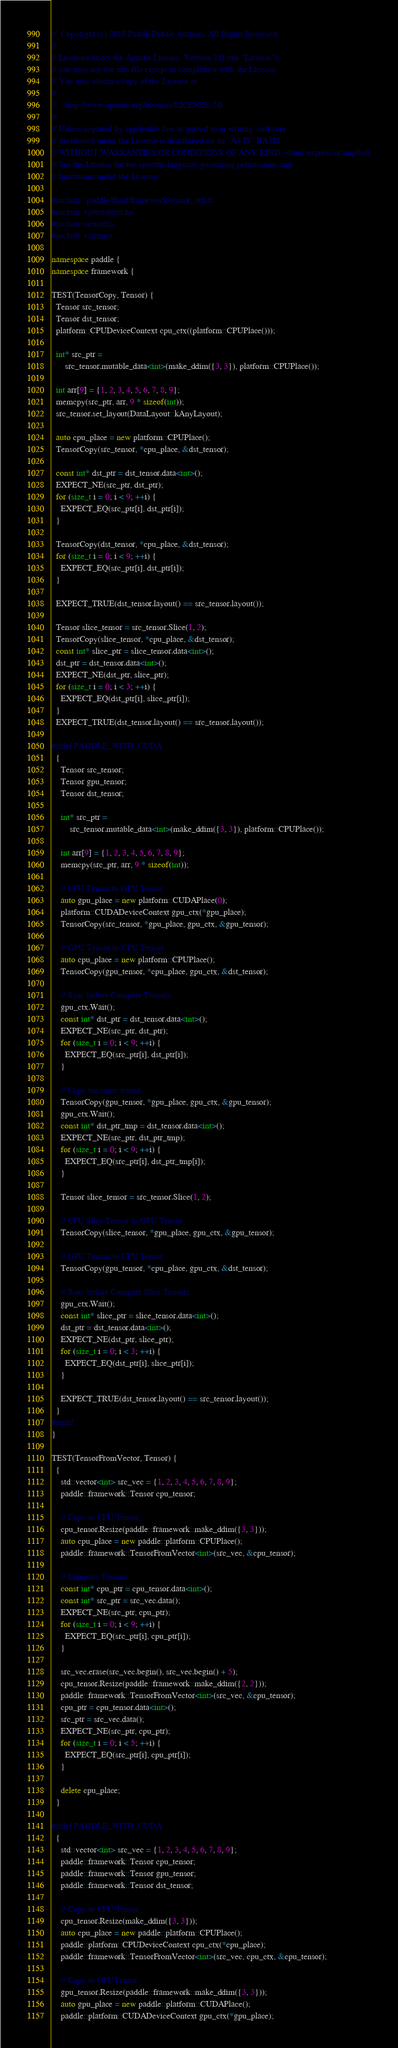<code> <loc_0><loc_0><loc_500><loc_500><_C++_>//  Copyright (c) 2018 PaddlePaddle Authors. All Rights Reserved.
//
// Licensed under the Apache License, Version 2.0 (the "License");
// you may not use this file except in compliance with the License.
// You may obtain a copy of the License at
//
//    http://www.apache.org/licenses/LICENSE-2.0
//
// Unless required by applicable law or agreed to in writing, software
// distributed under the License is distributed on an "AS IS" BASIS,
// WITHOUT WARRANTIES OR CONDITIONS OF ANY KIND, either express or implied.
// See the License for the specific language governing permissions and
// limitations under the License.

#include "paddle/fluid/framework/tensor_util.h"
#include <gtest/gtest.h>
#include <cmath>
#include <string>

namespace paddle {
namespace framework {

TEST(TensorCopy, Tensor) {
  Tensor src_tensor;
  Tensor dst_tensor;
  platform::CPUDeviceContext cpu_ctx((platform::CPUPlace()));

  int* src_ptr =
      src_tensor.mutable_data<int>(make_ddim({3, 3}), platform::CPUPlace());

  int arr[9] = {1, 2, 3, 4, 5, 6, 7, 8, 9};
  memcpy(src_ptr, arr, 9 * sizeof(int));
  src_tensor.set_layout(DataLayout::kAnyLayout);

  auto cpu_place = new platform::CPUPlace();
  TensorCopy(src_tensor, *cpu_place, &dst_tensor);

  const int* dst_ptr = dst_tensor.data<int>();
  EXPECT_NE(src_ptr, dst_ptr);
  for (size_t i = 0; i < 9; ++i) {
    EXPECT_EQ(src_ptr[i], dst_ptr[i]);
  }

  TensorCopy(dst_tensor, *cpu_place, &dst_tensor);
  for (size_t i = 0; i < 9; ++i) {
    EXPECT_EQ(src_ptr[i], dst_ptr[i]);
  }

  EXPECT_TRUE(dst_tensor.layout() == src_tensor.layout());

  Tensor slice_tensor = src_tensor.Slice(1, 2);
  TensorCopy(slice_tensor, *cpu_place, &dst_tensor);
  const int* slice_ptr = slice_tensor.data<int>();
  dst_ptr = dst_tensor.data<int>();
  EXPECT_NE(dst_ptr, slice_ptr);
  for (size_t i = 0; i < 3; ++i) {
    EXPECT_EQ(dst_ptr[i], slice_ptr[i]);
  }
  EXPECT_TRUE(dst_tensor.layout() == src_tensor.layout());

#ifdef PADDLE_WITH_CUDA
  {
    Tensor src_tensor;
    Tensor gpu_tensor;
    Tensor dst_tensor;

    int* src_ptr =
        src_tensor.mutable_data<int>(make_ddim({3, 3}), platform::CPUPlace());

    int arr[9] = {1, 2, 3, 4, 5, 6, 7, 8, 9};
    memcpy(src_ptr, arr, 9 * sizeof(int));

    // CPU Tensor to GPU Tensor
    auto gpu_place = new platform::CUDAPlace(0);
    platform::CUDADeviceContext gpu_ctx(*gpu_place);
    TensorCopy(src_tensor, *gpu_place, gpu_ctx, &gpu_tensor);

    // GPU Tensor to CPU Tensor
    auto cpu_place = new platform::CPUPlace();
    TensorCopy(gpu_tensor, *cpu_place, gpu_ctx, &dst_tensor);

    // Sync before Compare Tensors
    gpu_ctx.Wait();
    const int* dst_ptr = dst_tensor.data<int>();
    EXPECT_NE(src_ptr, dst_ptr);
    for (size_t i = 0; i < 9; ++i) {
      EXPECT_EQ(src_ptr[i], dst_ptr[i]);
    }

    // Copy the same tensor
    TensorCopy(gpu_tensor, *gpu_place, gpu_ctx, &gpu_tensor);
    gpu_ctx.Wait();
    const int* dst_ptr_tmp = dst_tensor.data<int>();
    EXPECT_NE(src_ptr, dst_ptr_tmp);
    for (size_t i = 0; i < 9; ++i) {
      EXPECT_EQ(src_ptr[i], dst_ptr_tmp[i]);
    }

    Tensor slice_tensor = src_tensor.Slice(1, 2);

    // CPU Slice Tensor to GPU Tensor
    TensorCopy(slice_tensor, *gpu_place, gpu_ctx, &gpu_tensor);

    // GPU Tensor to CPU Tensor
    TensorCopy(gpu_tensor, *cpu_place, gpu_ctx, &dst_tensor);

    // Sync before Compare Slice Tensors
    gpu_ctx.Wait();
    const int* slice_ptr = slice_tensor.data<int>();
    dst_ptr = dst_tensor.data<int>();
    EXPECT_NE(dst_ptr, slice_ptr);
    for (size_t i = 0; i < 3; ++i) {
      EXPECT_EQ(dst_ptr[i], slice_ptr[i]);
    }

    EXPECT_TRUE(dst_tensor.layout() == src_tensor.layout());
  }
#endif
}

TEST(TensorFromVector, Tensor) {
  {
    std::vector<int> src_vec = {1, 2, 3, 4, 5, 6, 7, 8, 9};
    paddle::framework::Tensor cpu_tensor;

    // Copy to CPU Tensor
    cpu_tensor.Resize(paddle::framework::make_ddim({3, 3}));
    auto cpu_place = new paddle::platform::CPUPlace();
    paddle::framework::TensorFromVector<int>(src_vec, &cpu_tensor);

    // Compare Tensors
    const int* cpu_ptr = cpu_tensor.data<int>();
    const int* src_ptr = src_vec.data();
    EXPECT_NE(src_ptr, cpu_ptr);
    for (size_t i = 0; i < 9; ++i) {
      EXPECT_EQ(src_ptr[i], cpu_ptr[i]);
    }

    src_vec.erase(src_vec.begin(), src_vec.begin() + 5);
    cpu_tensor.Resize(paddle::framework::make_ddim({2, 2}));
    paddle::framework::TensorFromVector<int>(src_vec, &cpu_tensor);
    cpu_ptr = cpu_tensor.data<int>();
    src_ptr = src_vec.data();
    EXPECT_NE(src_ptr, cpu_ptr);
    for (size_t i = 0; i < 5; ++i) {
      EXPECT_EQ(src_ptr[i], cpu_ptr[i]);
    }

    delete cpu_place;
  }

#ifdef PADDLE_WITH_CUDA
  {
    std::vector<int> src_vec = {1, 2, 3, 4, 5, 6, 7, 8, 9};
    paddle::framework::Tensor cpu_tensor;
    paddle::framework::Tensor gpu_tensor;
    paddle::framework::Tensor dst_tensor;

    // Copy to CPU Tensor
    cpu_tensor.Resize(make_ddim({3, 3}));
    auto cpu_place = new paddle::platform::CPUPlace();
    paddle::platform::CPUDeviceContext cpu_ctx(*cpu_place);
    paddle::framework::TensorFromVector<int>(src_vec, cpu_ctx, &cpu_tensor);

    // Copy to GPUTensor
    gpu_tensor.Resize(paddle::framework::make_ddim({3, 3}));
    auto gpu_place = new paddle::platform::CUDAPlace();
    paddle::platform::CUDADeviceContext gpu_ctx(*gpu_place);</code> 